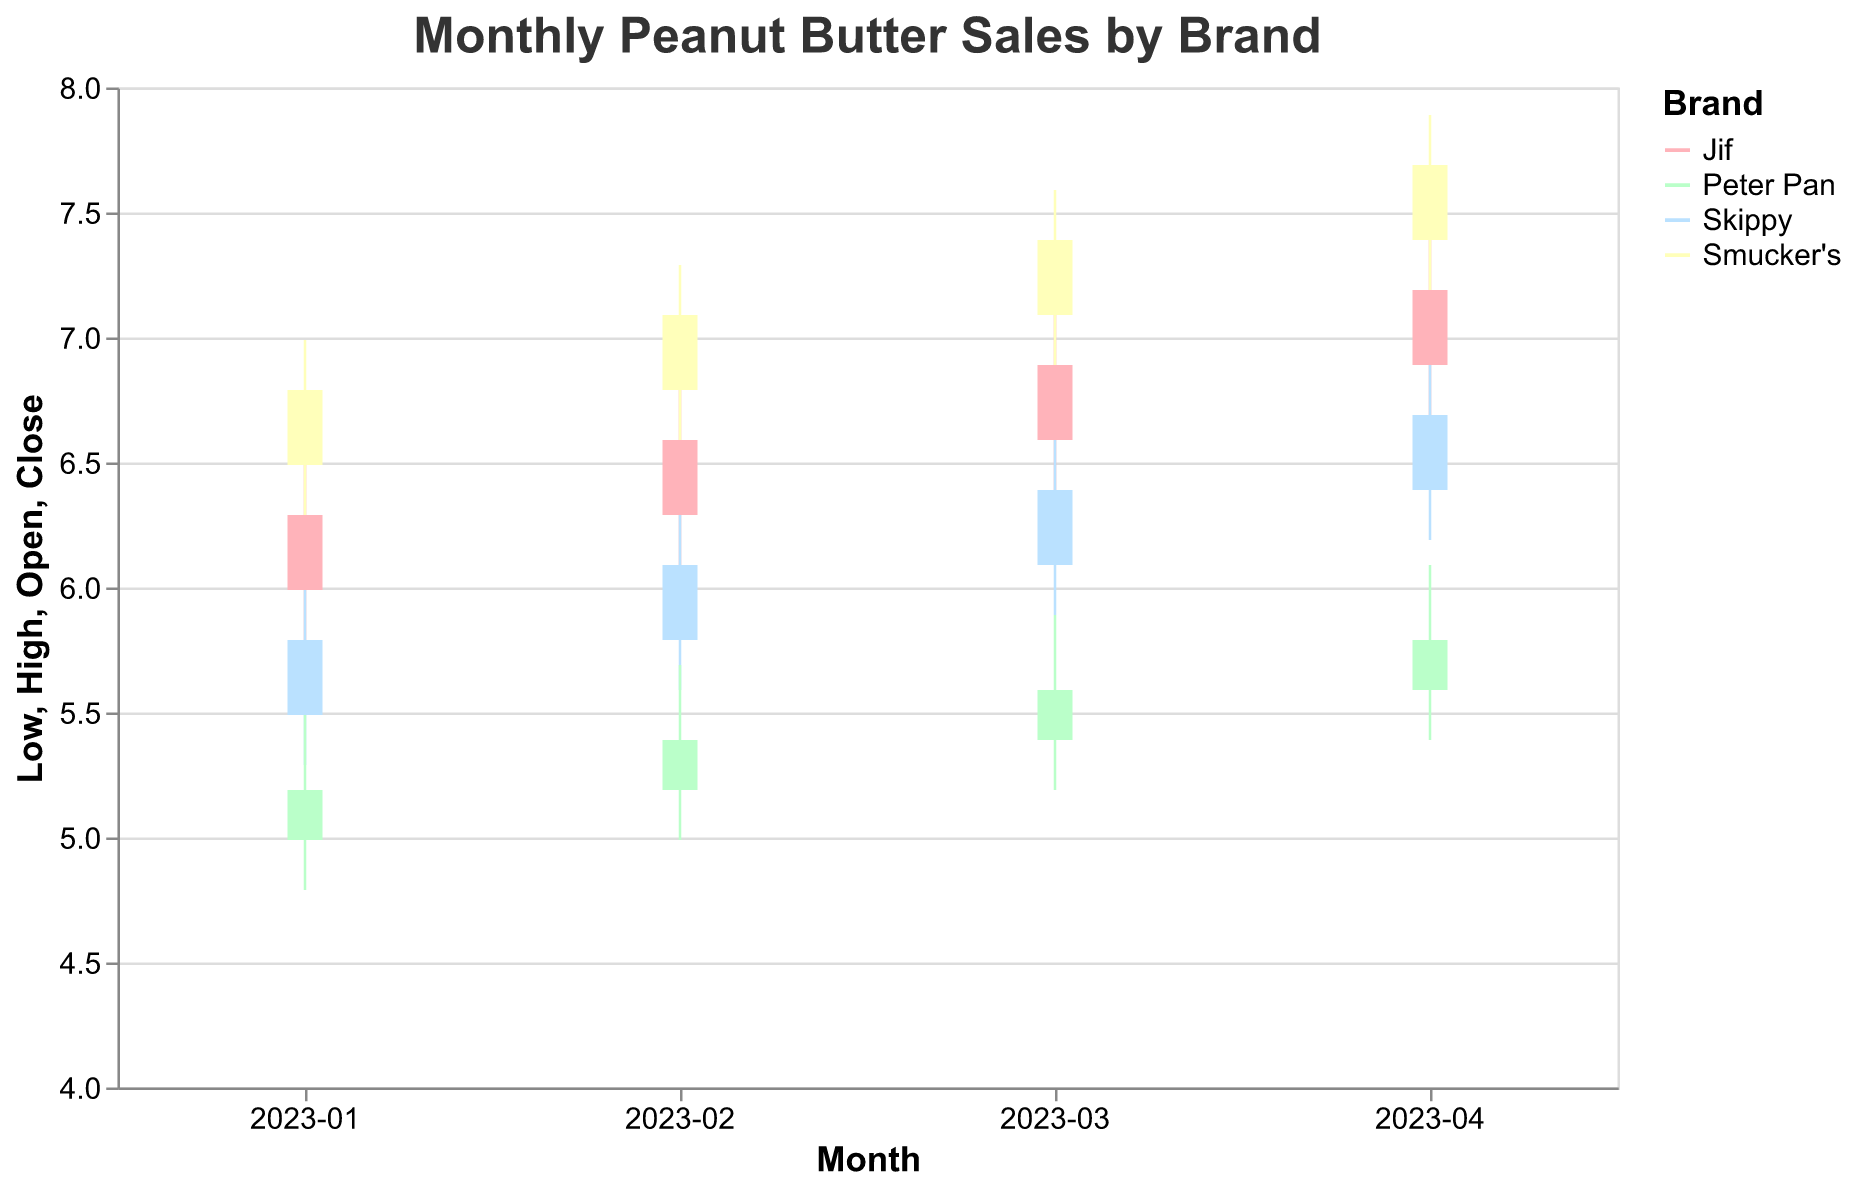Which brand had the highest closing price in January 2023? The highest closing price in January 2023 can be found by looking at the "Close" values for all brands in January. Smucker's had the highest closing price at 6.79.
Answer: Smucker's What was the average closing price for Jif across the four months? The average closing price for Jif can be calculated by summing the closing prices (6.29, 6.59, 6.89, 7.19) and dividing by the number of months (4). The sum is 26.96, so the average is 26.96 / 4 = 6.74.
Answer: 6.74 How did the opening price of Skippy in April 2023 compare to its closing price in January 2023? To compare the opening price of Skippy in April (6.39) to its closing price in January (5.79), note that the opening price in April was higher by 0.60 (6.39 - 5.79).
Answer: Higher by 0.60 Which brand had the least fluctuation in prices in February 2023? Price fluctuation can be determined by the range (High - Low). For February, the fluctuations for each brand are: Jif (6.79 - 6.09 = 0.7), Skippy (6.29 - 5.59 = 0.7), Peter Pan (5.69 - 4.99 = 0.7), and Smucker's (7.29 - 6.59 = 0.7). All brands had the same fluctuation of 0.7.
Answer: All brands Which brand experienced an increase in closing price every month from January to April 2023? To determine this, examine the closing prices for each brand across the months. Only Jif had rising closing prices: January (6.29), February (6.59), March (6.89), April (7.19).
Answer: Jif What was the total range of high prices across all brands in March 2023? The total range of high prices is calculated by subtracting the lowest high price from the highest high price in March. The high prices in March are: Jif (7.09), Skippy (6.59), Peter Pan (5.89), Smucker's (7.59). The range is 7.59 - 5.89 = 1.70.
Answer: 1.70 Which brand had the highest low price in April 2023? To find the highest low price in April, look at the "Low" values. Jif had the highest low price at 6.69.
Answer: Jif 